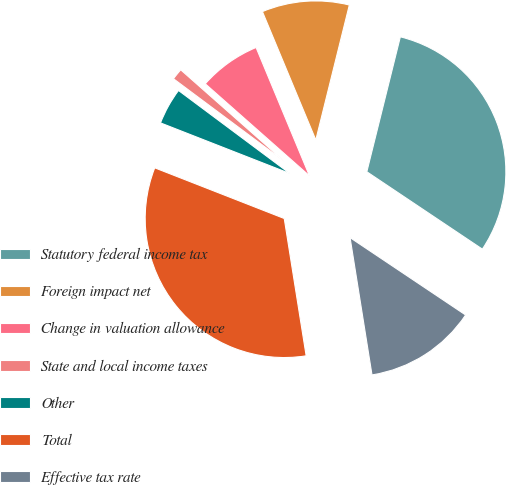Convert chart. <chart><loc_0><loc_0><loc_500><loc_500><pie_chart><fcel>Statutory federal income tax<fcel>Foreign impact net<fcel>Change in valuation allowance<fcel>State and local income taxes<fcel>Other<fcel>Total<fcel>Effective tax rate<nl><fcel>30.52%<fcel>10.15%<fcel>7.21%<fcel>1.32%<fcel>4.26%<fcel>33.46%<fcel>13.09%<nl></chart> 